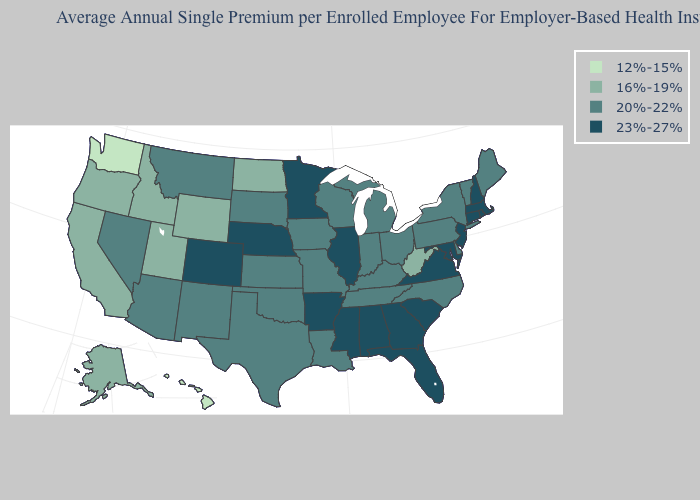What is the value of Maryland?
Short answer required. 23%-27%. What is the highest value in the USA?
Quick response, please. 23%-27%. Which states have the lowest value in the USA?
Give a very brief answer. Hawaii, Washington. What is the value of Rhode Island?
Short answer required. 23%-27%. Does Louisiana have the same value as Ohio?
Give a very brief answer. Yes. What is the value of Kansas?
Write a very short answer. 20%-22%. Is the legend a continuous bar?
Quick response, please. No. What is the value of South Dakota?
Give a very brief answer. 20%-22%. Which states have the highest value in the USA?
Give a very brief answer. Alabama, Arkansas, Colorado, Connecticut, Florida, Georgia, Illinois, Maryland, Massachusetts, Minnesota, Mississippi, Nebraska, New Hampshire, New Jersey, Rhode Island, South Carolina, Virginia. Name the states that have a value in the range 12%-15%?
Quick response, please. Hawaii, Washington. Does the map have missing data?
Write a very short answer. No. Name the states that have a value in the range 16%-19%?
Give a very brief answer. Alaska, California, Idaho, North Dakota, Oregon, Utah, West Virginia, Wyoming. What is the value of Michigan?
Concise answer only. 20%-22%. Name the states that have a value in the range 12%-15%?
Short answer required. Hawaii, Washington. Among the states that border Idaho , does Washington have the highest value?
Give a very brief answer. No. 